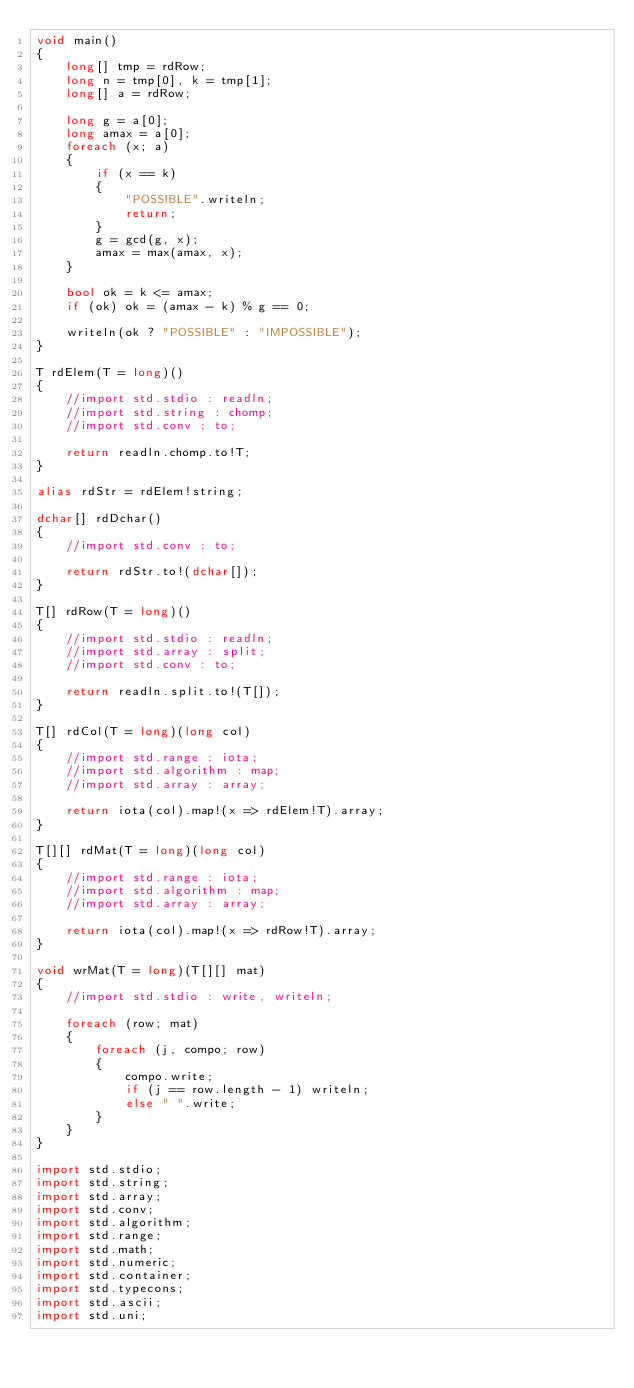<code> <loc_0><loc_0><loc_500><loc_500><_D_>void main()
{
    long[] tmp = rdRow;
    long n = tmp[0], k = tmp[1];
    long[] a = rdRow;

    long g = a[0];
    long amax = a[0];
    foreach (x; a)
    {
        if (x == k)
        {
            "POSSIBLE".writeln;
            return;
        }
        g = gcd(g, x);
        amax = max(amax, x);
    }

    bool ok = k <= amax;
    if (ok) ok = (amax - k) % g == 0;

    writeln(ok ? "POSSIBLE" : "IMPOSSIBLE");
}

T rdElem(T = long)()
{
    //import std.stdio : readln;
    //import std.string : chomp;
    //import std.conv : to;

    return readln.chomp.to!T;
}

alias rdStr = rdElem!string;

dchar[] rdDchar()
{
    //import std.conv : to;

    return rdStr.to!(dchar[]);
}

T[] rdRow(T = long)()
{
    //import std.stdio : readln;
    //import std.array : split;
    //import std.conv : to;

    return readln.split.to!(T[]);
}

T[] rdCol(T = long)(long col)
{
    //import std.range : iota;
    //import std.algorithm : map;
    //import std.array : array;

    return iota(col).map!(x => rdElem!T).array;
}

T[][] rdMat(T = long)(long col)
{
    //import std.range : iota;
    //import std.algorithm : map;
    //import std.array : array;

    return iota(col).map!(x => rdRow!T).array;
}

void wrMat(T = long)(T[][] mat)
{
    //import std.stdio : write, writeln;

    foreach (row; mat)
    {
        foreach (j, compo; row)
        {
            compo.write;
            if (j == row.length - 1) writeln;
            else " ".write;
        }
    }
}

import std.stdio;
import std.string;
import std.array;
import std.conv;
import std.algorithm;
import std.range;
import std.math;
import std.numeric;
import std.container;
import std.typecons;
import std.ascii;
import std.uni;</code> 